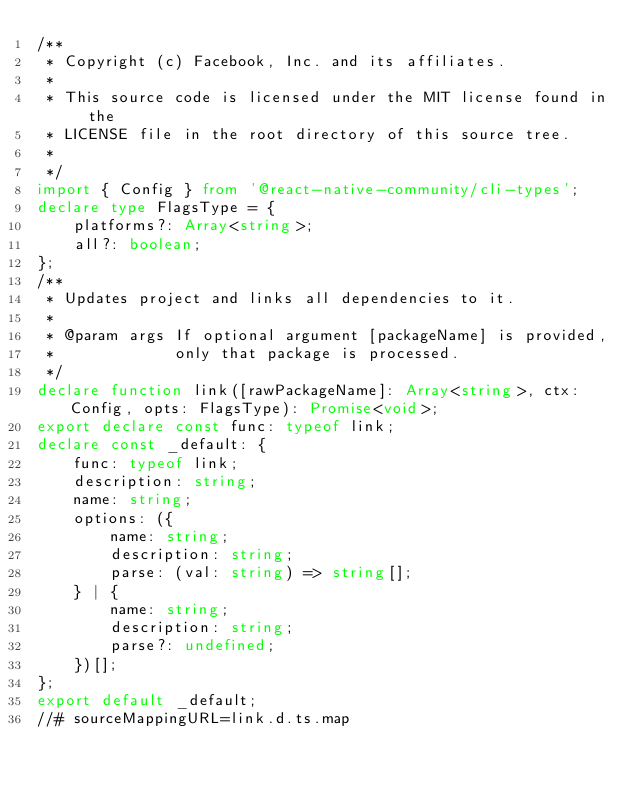Convert code to text. <code><loc_0><loc_0><loc_500><loc_500><_TypeScript_>/**
 * Copyright (c) Facebook, Inc. and its affiliates.
 *
 * This source code is licensed under the MIT license found in the
 * LICENSE file in the root directory of this source tree.
 *
 */
import { Config } from '@react-native-community/cli-types';
declare type FlagsType = {
    platforms?: Array<string>;
    all?: boolean;
};
/**
 * Updates project and links all dependencies to it.
 *
 * @param args If optional argument [packageName] is provided,
 *             only that package is processed.
 */
declare function link([rawPackageName]: Array<string>, ctx: Config, opts: FlagsType): Promise<void>;
export declare const func: typeof link;
declare const _default: {
    func: typeof link;
    description: string;
    name: string;
    options: ({
        name: string;
        description: string;
        parse: (val: string) => string[];
    } | {
        name: string;
        description: string;
        parse?: undefined;
    })[];
};
export default _default;
//# sourceMappingURL=link.d.ts.map</code> 